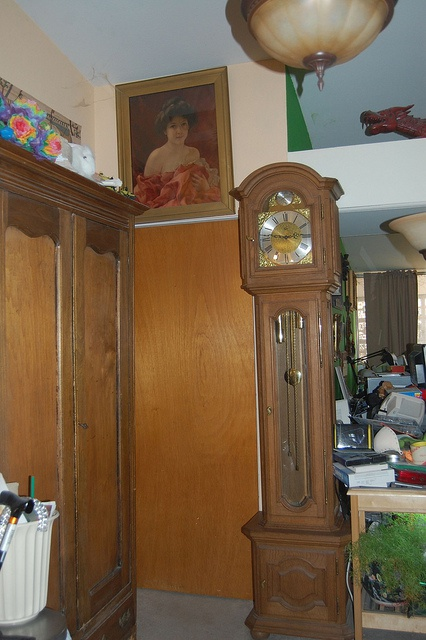Describe the objects in this image and their specific colors. I can see potted plant in darkgray, darkgreen, black, and gray tones, clock in darkgray, tan, gray, and olive tones, people in darkgray, brown, black, gray, and maroon tones, book in darkgray, black, gray, and darkblue tones, and book in darkgray, lightgray, and gray tones in this image. 